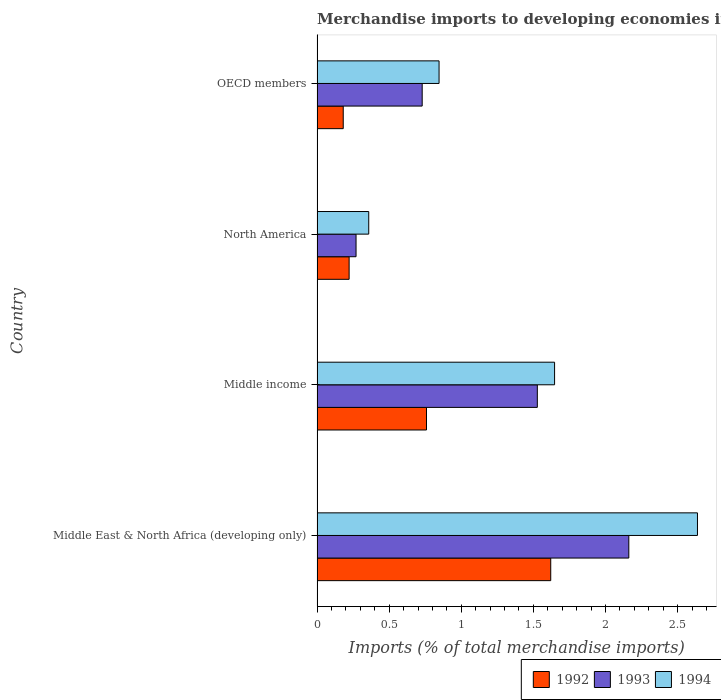Are the number of bars per tick equal to the number of legend labels?
Offer a very short reply. Yes. How many bars are there on the 4th tick from the top?
Your response must be concise. 3. How many bars are there on the 4th tick from the bottom?
Ensure brevity in your answer.  3. What is the label of the 4th group of bars from the top?
Make the answer very short. Middle East & North Africa (developing only). What is the percentage total merchandise imports in 1992 in Middle income?
Ensure brevity in your answer.  0.76. Across all countries, what is the maximum percentage total merchandise imports in 1994?
Ensure brevity in your answer.  2.64. Across all countries, what is the minimum percentage total merchandise imports in 1993?
Give a very brief answer. 0.27. In which country was the percentage total merchandise imports in 1993 maximum?
Provide a succinct answer. Middle East & North Africa (developing only). In which country was the percentage total merchandise imports in 1993 minimum?
Offer a terse response. North America. What is the total percentage total merchandise imports in 1992 in the graph?
Your response must be concise. 2.78. What is the difference between the percentage total merchandise imports in 1994 in Middle East & North Africa (developing only) and that in OECD members?
Keep it short and to the point. 1.79. What is the difference between the percentage total merchandise imports in 1992 in Middle income and the percentage total merchandise imports in 1993 in Middle East & North Africa (developing only)?
Ensure brevity in your answer.  -1.4. What is the average percentage total merchandise imports in 1994 per country?
Offer a terse response. 1.37. What is the difference between the percentage total merchandise imports in 1992 and percentage total merchandise imports in 1993 in North America?
Provide a succinct answer. -0.05. In how many countries, is the percentage total merchandise imports in 1993 greater than 0.9 %?
Provide a succinct answer. 2. What is the ratio of the percentage total merchandise imports in 1993 in North America to that in OECD members?
Offer a very short reply. 0.37. Is the percentage total merchandise imports in 1992 in Middle East & North Africa (developing only) less than that in Middle income?
Offer a very short reply. No. Is the difference between the percentage total merchandise imports in 1992 in Middle income and OECD members greater than the difference between the percentage total merchandise imports in 1993 in Middle income and OECD members?
Make the answer very short. No. What is the difference between the highest and the second highest percentage total merchandise imports in 1992?
Make the answer very short. 0.86. What is the difference between the highest and the lowest percentage total merchandise imports in 1994?
Your answer should be compact. 2.28. Is the sum of the percentage total merchandise imports in 1992 in Middle income and OECD members greater than the maximum percentage total merchandise imports in 1994 across all countries?
Your answer should be very brief. No. What does the 3rd bar from the top in Middle income represents?
Keep it short and to the point. 1992. What does the 1st bar from the bottom in Middle East & North Africa (developing only) represents?
Offer a terse response. 1992. What is the difference between two consecutive major ticks on the X-axis?
Give a very brief answer. 0.5. Does the graph contain grids?
Offer a very short reply. No. How many legend labels are there?
Give a very brief answer. 3. How are the legend labels stacked?
Provide a succinct answer. Horizontal. What is the title of the graph?
Provide a short and direct response. Merchandise imports to developing economies in Europe. Does "2015" appear as one of the legend labels in the graph?
Make the answer very short. No. What is the label or title of the X-axis?
Offer a very short reply. Imports (% of total merchandise imports). What is the Imports (% of total merchandise imports) of 1992 in Middle East & North Africa (developing only)?
Offer a very short reply. 1.62. What is the Imports (% of total merchandise imports) in 1993 in Middle East & North Africa (developing only)?
Your response must be concise. 2.16. What is the Imports (% of total merchandise imports) in 1994 in Middle East & North Africa (developing only)?
Provide a short and direct response. 2.64. What is the Imports (% of total merchandise imports) in 1992 in Middle income?
Your answer should be compact. 0.76. What is the Imports (% of total merchandise imports) of 1993 in Middle income?
Give a very brief answer. 1.53. What is the Imports (% of total merchandise imports) of 1994 in Middle income?
Offer a terse response. 1.65. What is the Imports (% of total merchandise imports) of 1992 in North America?
Ensure brevity in your answer.  0.22. What is the Imports (% of total merchandise imports) in 1993 in North America?
Give a very brief answer. 0.27. What is the Imports (% of total merchandise imports) of 1994 in North America?
Provide a short and direct response. 0.36. What is the Imports (% of total merchandise imports) in 1992 in OECD members?
Offer a terse response. 0.18. What is the Imports (% of total merchandise imports) of 1993 in OECD members?
Provide a succinct answer. 0.73. What is the Imports (% of total merchandise imports) of 1994 in OECD members?
Your response must be concise. 0.85. Across all countries, what is the maximum Imports (% of total merchandise imports) in 1992?
Make the answer very short. 1.62. Across all countries, what is the maximum Imports (% of total merchandise imports) in 1993?
Make the answer very short. 2.16. Across all countries, what is the maximum Imports (% of total merchandise imports) of 1994?
Your answer should be very brief. 2.64. Across all countries, what is the minimum Imports (% of total merchandise imports) in 1992?
Your answer should be compact. 0.18. Across all countries, what is the minimum Imports (% of total merchandise imports) in 1993?
Make the answer very short. 0.27. Across all countries, what is the minimum Imports (% of total merchandise imports) of 1994?
Give a very brief answer. 0.36. What is the total Imports (% of total merchandise imports) in 1992 in the graph?
Offer a terse response. 2.78. What is the total Imports (% of total merchandise imports) in 1993 in the graph?
Make the answer very short. 4.69. What is the total Imports (% of total merchandise imports) in 1994 in the graph?
Your answer should be very brief. 5.49. What is the difference between the Imports (% of total merchandise imports) of 1992 in Middle East & North Africa (developing only) and that in Middle income?
Your answer should be compact. 0.86. What is the difference between the Imports (% of total merchandise imports) of 1993 in Middle East & North Africa (developing only) and that in Middle income?
Give a very brief answer. 0.63. What is the difference between the Imports (% of total merchandise imports) in 1994 in Middle East & North Africa (developing only) and that in Middle income?
Ensure brevity in your answer.  0.99. What is the difference between the Imports (% of total merchandise imports) in 1992 in Middle East & North Africa (developing only) and that in North America?
Your answer should be compact. 1.4. What is the difference between the Imports (% of total merchandise imports) of 1993 in Middle East & North Africa (developing only) and that in North America?
Your answer should be very brief. 1.89. What is the difference between the Imports (% of total merchandise imports) of 1994 in Middle East & North Africa (developing only) and that in North America?
Keep it short and to the point. 2.28. What is the difference between the Imports (% of total merchandise imports) in 1992 in Middle East & North Africa (developing only) and that in OECD members?
Give a very brief answer. 1.44. What is the difference between the Imports (% of total merchandise imports) in 1993 in Middle East & North Africa (developing only) and that in OECD members?
Offer a terse response. 1.43. What is the difference between the Imports (% of total merchandise imports) in 1994 in Middle East & North Africa (developing only) and that in OECD members?
Offer a very short reply. 1.79. What is the difference between the Imports (% of total merchandise imports) in 1992 in Middle income and that in North America?
Your answer should be compact. 0.54. What is the difference between the Imports (% of total merchandise imports) in 1993 in Middle income and that in North America?
Provide a succinct answer. 1.26. What is the difference between the Imports (% of total merchandise imports) of 1994 in Middle income and that in North America?
Make the answer very short. 1.29. What is the difference between the Imports (% of total merchandise imports) in 1992 in Middle income and that in OECD members?
Provide a short and direct response. 0.58. What is the difference between the Imports (% of total merchandise imports) in 1993 in Middle income and that in OECD members?
Keep it short and to the point. 0.8. What is the difference between the Imports (% of total merchandise imports) in 1994 in Middle income and that in OECD members?
Offer a very short reply. 0.8. What is the difference between the Imports (% of total merchandise imports) of 1992 in North America and that in OECD members?
Offer a very short reply. 0.04. What is the difference between the Imports (% of total merchandise imports) of 1993 in North America and that in OECD members?
Your answer should be very brief. -0.46. What is the difference between the Imports (% of total merchandise imports) of 1994 in North America and that in OECD members?
Ensure brevity in your answer.  -0.49. What is the difference between the Imports (% of total merchandise imports) of 1992 in Middle East & North Africa (developing only) and the Imports (% of total merchandise imports) of 1993 in Middle income?
Ensure brevity in your answer.  0.09. What is the difference between the Imports (% of total merchandise imports) of 1992 in Middle East & North Africa (developing only) and the Imports (% of total merchandise imports) of 1994 in Middle income?
Provide a succinct answer. -0.03. What is the difference between the Imports (% of total merchandise imports) in 1993 in Middle East & North Africa (developing only) and the Imports (% of total merchandise imports) in 1994 in Middle income?
Provide a succinct answer. 0.51. What is the difference between the Imports (% of total merchandise imports) of 1992 in Middle East & North Africa (developing only) and the Imports (% of total merchandise imports) of 1993 in North America?
Offer a terse response. 1.35. What is the difference between the Imports (% of total merchandise imports) in 1992 in Middle East & North Africa (developing only) and the Imports (% of total merchandise imports) in 1994 in North America?
Offer a terse response. 1.26. What is the difference between the Imports (% of total merchandise imports) in 1993 in Middle East & North Africa (developing only) and the Imports (% of total merchandise imports) in 1994 in North America?
Make the answer very short. 1.8. What is the difference between the Imports (% of total merchandise imports) in 1992 in Middle East & North Africa (developing only) and the Imports (% of total merchandise imports) in 1993 in OECD members?
Your response must be concise. 0.89. What is the difference between the Imports (% of total merchandise imports) of 1992 in Middle East & North Africa (developing only) and the Imports (% of total merchandise imports) of 1994 in OECD members?
Keep it short and to the point. 0.77. What is the difference between the Imports (% of total merchandise imports) in 1993 in Middle East & North Africa (developing only) and the Imports (% of total merchandise imports) in 1994 in OECD members?
Give a very brief answer. 1.32. What is the difference between the Imports (% of total merchandise imports) of 1992 in Middle income and the Imports (% of total merchandise imports) of 1993 in North America?
Provide a short and direct response. 0.49. What is the difference between the Imports (% of total merchandise imports) in 1992 in Middle income and the Imports (% of total merchandise imports) in 1994 in North America?
Offer a terse response. 0.4. What is the difference between the Imports (% of total merchandise imports) in 1993 in Middle income and the Imports (% of total merchandise imports) in 1994 in North America?
Provide a short and direct response. 1.17. What is the difference between the Imports (% of total merchandise imports) in 1992 in Middle income and the Imports (% of total merchandise imports) in 1993 in OECD members?
Offer a terse response. 0.03. What is the difference between the Imports (% of total merchandise imports) in 1992 in Middle income and the Imports (% of total merchandise imports) in 1994 in OECD members?
Your answer should be compact. -0.09. What is the difference between the Imports (% of total merchandise imports) of 1993 in Middle income and the Imports (% of total merchandise imports) of 1994 in OECD members?
Offer a very short reply. 0.68. What is the difference between the Imports (% of total merchandise imports) in 1992 in North America and the Imports (% of total merchandise imports) in 1993 in OECD members?
Offer a terse response. -0.51. What is the difference between the Imports (% of total merchandise imports) in 1992 in North America and the Imports (% of total merchandise imports) in 1994 in OECD members?
Your response must be concise. -0.62. What is the difference between the Imports (% of total merchandise imports) in 1993 in North America and the Imports (% of total merchandise imports) in 1994 in OECD members?
Offer a very short reply. -0.58. What is the average Imports (% of total merchandise imports) in 1992 per country?
Your answer should be compact. 0.7. What is the average Imports (% of total merchandise imports) of 1993 per country?
Make the answer very short. 1.17. What is the average Imports (% of total merchandise imports) in 1994 per country?
Your answer should be very brief. 1.37. What is the difference between the Imports (% of total merchandise imports) of 1992 and Imports (% of total merchandise imports) of 1993 in Middle East & North Africa (developing only)?
Keep it short and to the point. -0.54. What is the difference between the Imports (% of total merchandise imports) of 1992 and Imports (% of total merchandise imports) of 1994 in Middle East & North Africa (developing only)?
Offer a very short reply. -1.02. What is the difference between the Imports (% of total merchandise imports) of 1993 and Imports (% of total merchandise imports) of 1994 in Middle East & North Africa (developing only)?
Your response must be concise. -0.48. What is the difference between the Imports (% of total merchandise imports) in 1992 and Imports (% of total merchandise imports) in 1993 in Middle income?
Keep it short and to the point. -0.77. What is the difference between the Imports (% of total merchandise imports) in 1992 and Imports (% of total merchandise imports) in 1994 in Middle income?
Provide a short and direct response. -0.89. What is the difference between the Imports (% of total merchandise imports) of 1993 and Imports (% of total merchandise imports) of 1994 in Middle income?
Your answer should be very brief. -0.12. What is the difference between the Imports (% of total merchandise imports) in 1992 and Imports (% of total merchandise imports) in 1993 in North America?
Keep it short and to the point. -0.05. What is the difference between the Imports (% of total merchandise imports) in 1992 and Imports (% of total merchandise imports) in 1994 in North America?
Your answer should be compact. -0.14. What is the difference between the Imports (% of total merchandise imports) in 1993 and Imports (% of total merchandise imports) in 1994 in North America?
Ensure brevity in your answer.  -0.09. What is the difference between the Imports (% of total merchandise imports) of 1992 and Imports (% of total merchandise imports) of 1993 in OECD members?
Keep it short and to the point. -0.55. What is the difference between the Imports (% of total merchandise imports) in 1992 and Imports (% of total merchandise imports) in 1994 in OECD members?
Give a very brief answer. -0.66. What is the difference between the Imports (% of total merchandise imports) of 1993 and Imports (% of total merchandise imports) of 1994 in OECD members?
Keep it short and to the point. -0.12. What is the ratio of the Imports (% of total merchandise imports) in 1992 in Middle East & North Africa (developing only) to that in Middle income?
Your answer should be compact. 2.14. What is the ratio of the Imports (% of total merchandise imports) in 1993 in Middle East & North Africa (developing only) to that in Middle income?
Give a very brief answer. 1.42. What is the ratio of the Imports (% of total merchandise imports) in 1994 in Middle East & North Africa (developing only) to that in Middle income?
Your answer should be very brief. 1.6. What is the ratio of the Imports (% of total merchandise imports) in 1992 in Middle East & North Africa (developing only) to that in North America?
Keep it short and to the point. 7.28. What is the ratio of the Imports (% of total merchandise imports) in 1993 in Middle East & North Africa (developing only) to that in North America?
Ensure brevity in your answer.  8. What is the ratio of the Imports (% of total merchandise imports) in 1994 in Middle East & North Africa (developing only) to that in North America?
Offer a terse response. 7.36. What is the ratio of the Imports (% of total merchandise imports) in 1992 in Middle East & North Africa (developing only) to that in OECD members?
Your response must be concise. 8.92. What is the ratio of the Imports (% of total merchandise imports) of 1993 in Middle East & North Africa (developing only) to that in OECD members?
Give a very brief answer. 2.97. What is the ratio of the Imports (% of total merchandise imports) of 1994 in Middle East & North Africa (developing only) to that in OECD members?
Offer a terse response. 3.12. What is the ratio of the Imports (% of total merchandise imports) of 1992 in Middle income to that in North America?
Offer a terse response. 3.41. What is the ratio of the Imports (% of total merchandise imports) of 1993 in Middle income to that in North America?
Provide a succinct answer. 5.65. What is the ratio of the Imports (% of total merchandise imports) of 1994 in Middle income to that in North America?
Provide a succinct answer. 4.6. What is the ratio of the Imports (% of total merchandise imports) of 1992 in Middle income to that in OECD members?
Offer a very short reply. 4.18. What is the ratio of the Imports (% of total merchandise imports) of 1993 in Middle income to that in OECD members?
Keep it short and to the point. 2.1. What is the ratio of the Imports (% of total merchandise imports) of 1994 in Middle income to that in OECD members?
Offer a very short reply. 1.95. What is the ratio of the Imports (% of total merchandise imports) in 1992 in North America to that in OECD members?
Give a very brief answer. 1.23. What is the ratio of the Imports (% of total merchandise imports) in 1993 in North America to that in OECD members?
Your answer should be very brief. 0.37. What is the ratio of the Imports (% of total merchandise imports) in 1994 in North America to that in OECD members?
Your answer should be compact. 0.42. What is the difference between the highest and the second highest Imports (% of total merchandise imports) of 1992?
Provide a short and direct response. 0.86. What is the difference between the highest and the second highest Imports (% of total merchandise imports) of 1993?
Offer a terse response. 0.63. What is the difference between the highest and the second highest Imports (% of total merchandise imports) in 1994?
Make the answer very short. 0.99. What is the difference between the highest and the lowest Imports (% of total merchandise imports) in 1992?
Offer a terse response. 1.44. What is the difference between the highest and the lowest Imports (% of total merchandise imports) of 1993?
Your answer should be compact. 1.89. What is the difference between the highest and the lowest Imports (% of total merchandise imports) in 1994?
Offer a terse response. 2.28. 